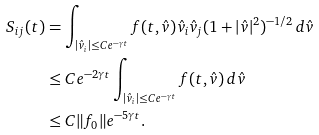<formula> <loc_0><loc_0><loc_500><loc_500>S _ { i j } ( t ) & = \int _ { | \hat { v } _ { i } | \leq C e ^ { - \gamma t } } f ( t , \hat { v } ) \hat { v } _ { i } \hat { v } _ { j } ( 1 + | \hat { v } | ^ { 2 } ) ^ { - 1 / 2 } \, d \hat { v } \\ & \leq C e ^ { - 2 \gamma t } \int _ { | \hat { v } _ { i } | \leq C e ^ { - \gamma t } } f ( t , \hat { v } ) \, d \hat { v } \\ & \leq C \| f _ { 0 } \| e ^ { - 5 \gamma t } .</formula> 